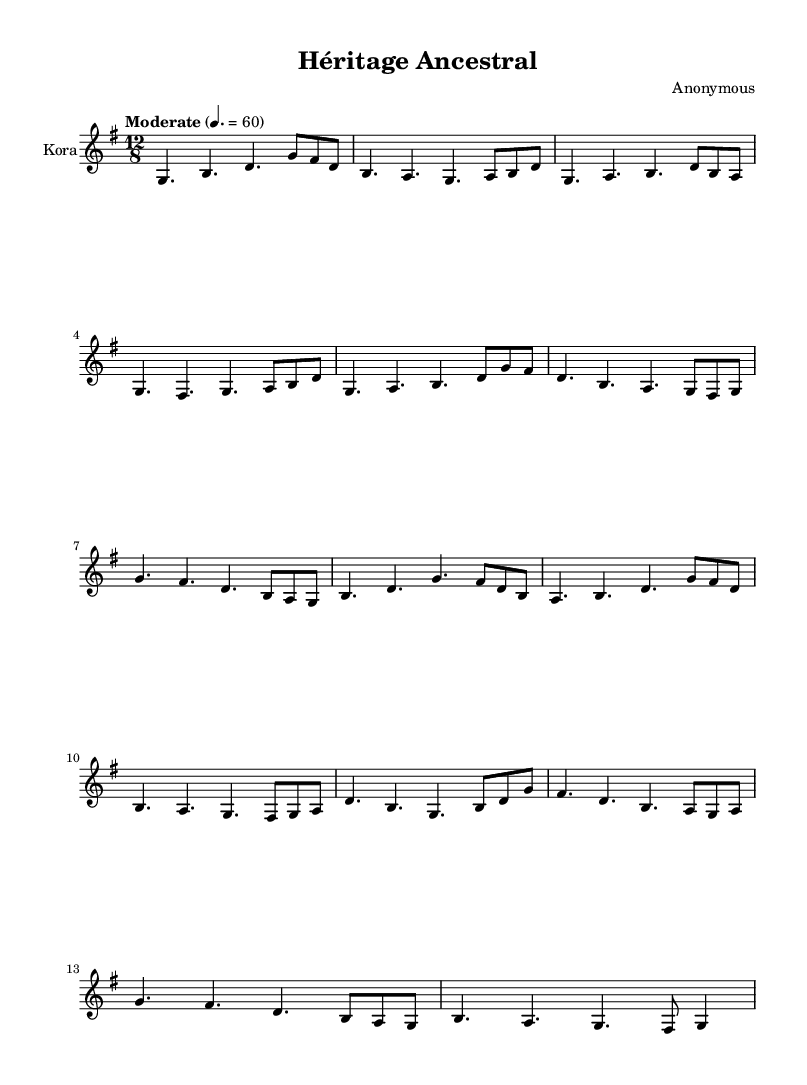What is the key signature of this music? The key signature is G major, which has one sharp (F#). You can identify it at the beginning of the staff where the sharp is placed on the F line.
Answer: G major What is the time signature of this music? The time signature is 12/8, which indicates there are 12 eighth notes per measure. This can be found at the beginning of the piece next to the key signature.
Answer: 12/8 What is the tempo marking for this piece? The tempo marking is "Moderate" with a metronome marking of 60 beats per minute, indicated near the beginning of the score.
Answer: Moderate How many measures are in the introduction section? There are 2 measures in the introduction section, as determined by counting the bar lines at the end of the introductory phrases.
Answer: 2 In which section does the note sequence begin with G, F#, D? This sequence appears in the chorus section starting with the first note of the bar under that section heading.
Answer: Chorus How does the outro section start? The outro section starts with the note G in the first measure and is followed by an F#, D, B sequence, visible in the last section of the score.
Answer: G What instrument is indicated in the score? The instrument indicated in the score is the Kora, which is specified at the beginning of the staff where it states "Kora".
Answer: Kora 